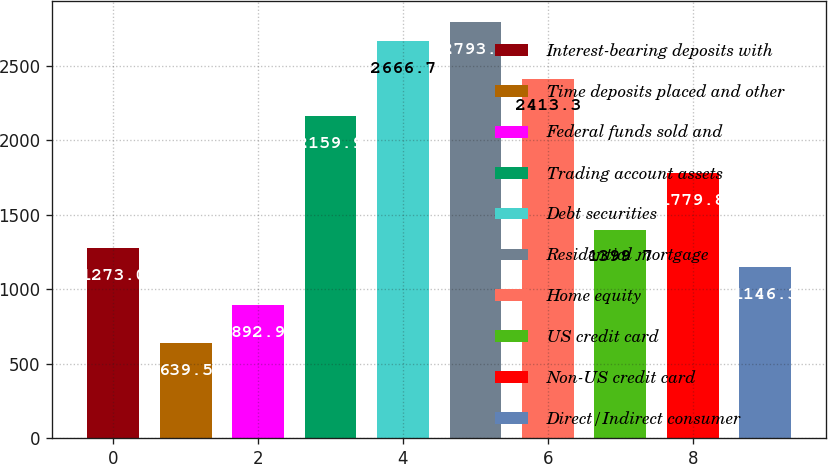<chart> <loc_0><loc_0><loc_500><loc_500><bar_chart><fcel>Interest-bearing deposits with<fcel>Time deposits placed and other<fcel>Federal funds sold and<fcel>Trading account assets<fcel>Debt securities<fcel>Residential mortgage<fcel>Home equity<fcel>US credit card<fcel>Non-US credit card<fcel>Direct/Indirect consumer<nl><fcel>1273<fcel>639.5<fcel>892.9<fcel>2159.9<fcel>2666.7<fcel>2793.4<fcel>2413.3<fcel>1399.7<fcel>1779.8<fcel>1146.3<nl></chart> 